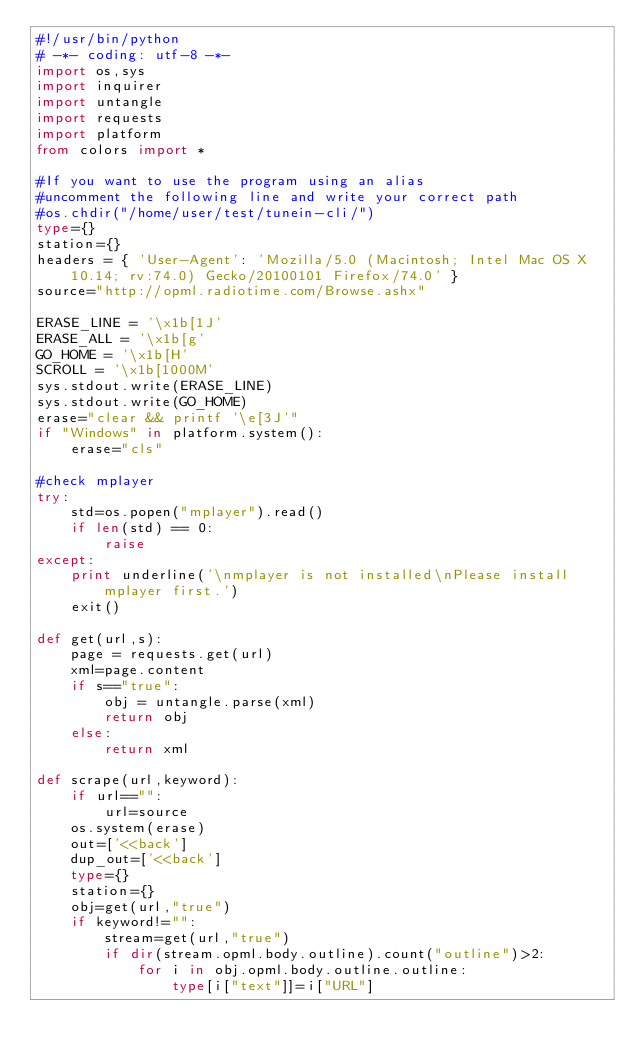Convert code to text. <code><loc_0><loc_0><loc_500><loc_500><_Python_>#!/usr/bin/python
# -*- coding: utf-8 -*-
import os,sys
import inquirer
import untangle
import requests
import platform
from colors import *

#If you want to use the program using an alias
#uncomment the following line and write your correct path
#os.chdir("/home/user/test/tunein-cli/")
type={}
station={}
headers = { 'User-Agent': 'Mozilla/5.0 (Macintosh; Intel Mac OS X 10.14; rv:74.0) Gecko/20100101 Firefox/74.0' }
source="http://opml.radiotime.com/Browse.ashx"

ERASE_LINE = '\x1b[1J'
ERASE_ALL = '\x1b[g'
GO_HOME = '\x1b[H'
SCROLL = '\x1b[1000M'
sys.stdout.write(ERASE_LINE)
sys.stdout.write(GO_HOME)
erase="clear && printf '\e[3J'"
if "Windows" in platform.system():
    erase="cls"

#check mplayer
try:
    std=os.popen("mplayer").read()
    if len(std) == 0:
        raise
except:
    print underline('\nmplayer is not installed\nPlease install mplayer first.')
    exit()

def get(url,s):
    page = requests.get(url)
    xml=page.content
    if s=="true":
        obj = untangle.parse(xml)
        return obj
    else:
        return xml

def scrape(url,keyword):
    if url=="":
        url=source
    os.system(erase)
    out=['<<back']
    dup_out=['<<back']
    type={}
    station={}
    obj=get(url,"true")
    if keyword!="":
        stream=get(url,"true")
        if dir(stream.opml.body.outline).count("outline")>2:
            for i in obj.opml.body.outline.outline:
                type[i["text"]]=i["URL"]</code> 